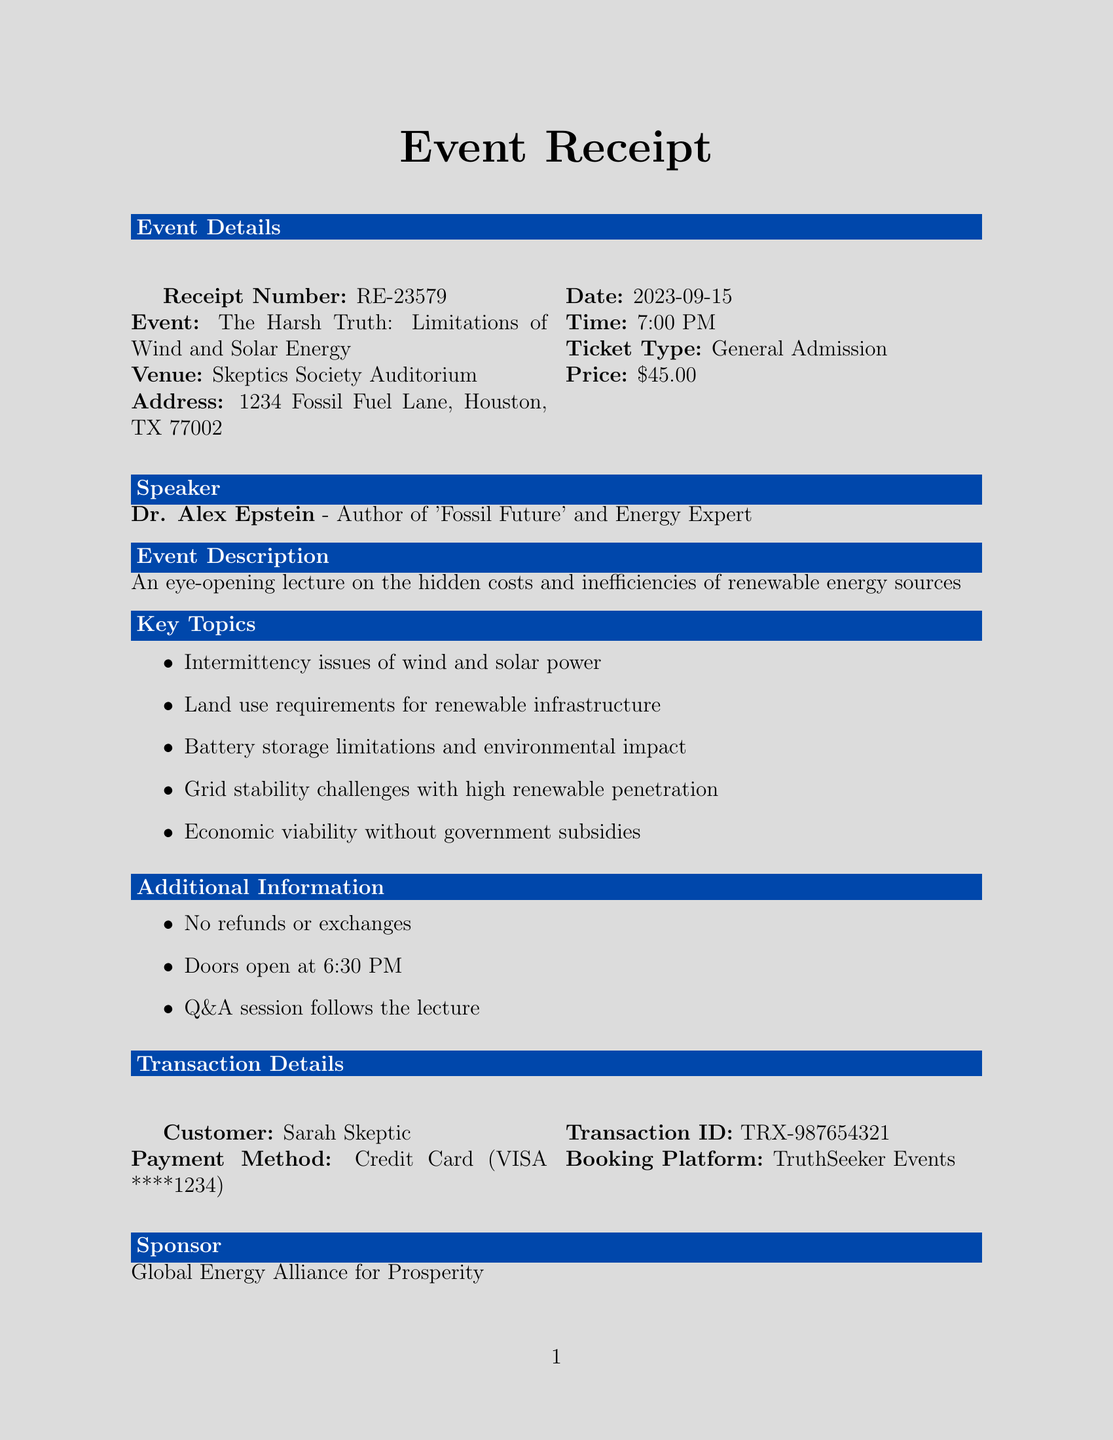What is the receipt number? The receipt number is stated at the top of the document for identification purposes.
Answer: RE-23579 Who is the speaker? The document lists the speaker's name and credentials related to the event.
Answer: Dr. Alex Epstein What is the ticket price? The document specifies the price associated with the ticket type provided in the event details.
Answer: $45.00 What is the event date? The event date is clearly mentioned in the event details section of the document.
Answer: 2023-09-15 What are the key topics discussed? The document lists several key topics that will be covered in the lecture.
Answer: Intermittency issues of wind and solar power What time do doors open? The document includes specific information about the timing for attendees to enter the venue.
Answer: 6:30 PM Is there a refund policy mentioned? The document clearly states the policy regarding refunds or exchanges for the event.
Answer: No refunds or exchanges What is the name of the sponsor? The sponsor's name is mentioned in a dedicated section of the document.
Answer: Global Energy Alliance for Prosperity What is the booking platform used? The platform used for booking tickets is highlighted in the transaction details section.
Answer: TruthSeeker Events 